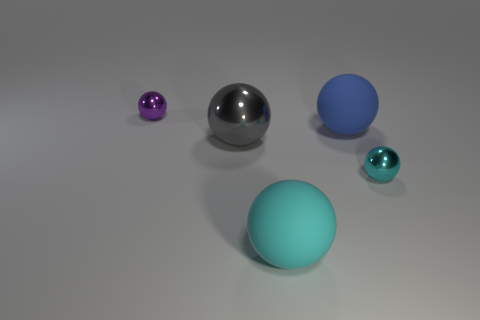Subtract all gray spheres. How many spheres are left? 4 Subtract all gray spheres. Subtract all blue cylinders. How many spheres are left? 4 Add 4 yellow shiny cubes. How many objects exist? 9 Add 2 tiny balls. How many tiny balls are left? 4 Add 4 small objects. How many small objects exist? 6 Subtract 0 yellow cubes. How many objects are left? 5 Subtract all big cyan things. Subtract all large purple metal objects. How many objects are left? 4 